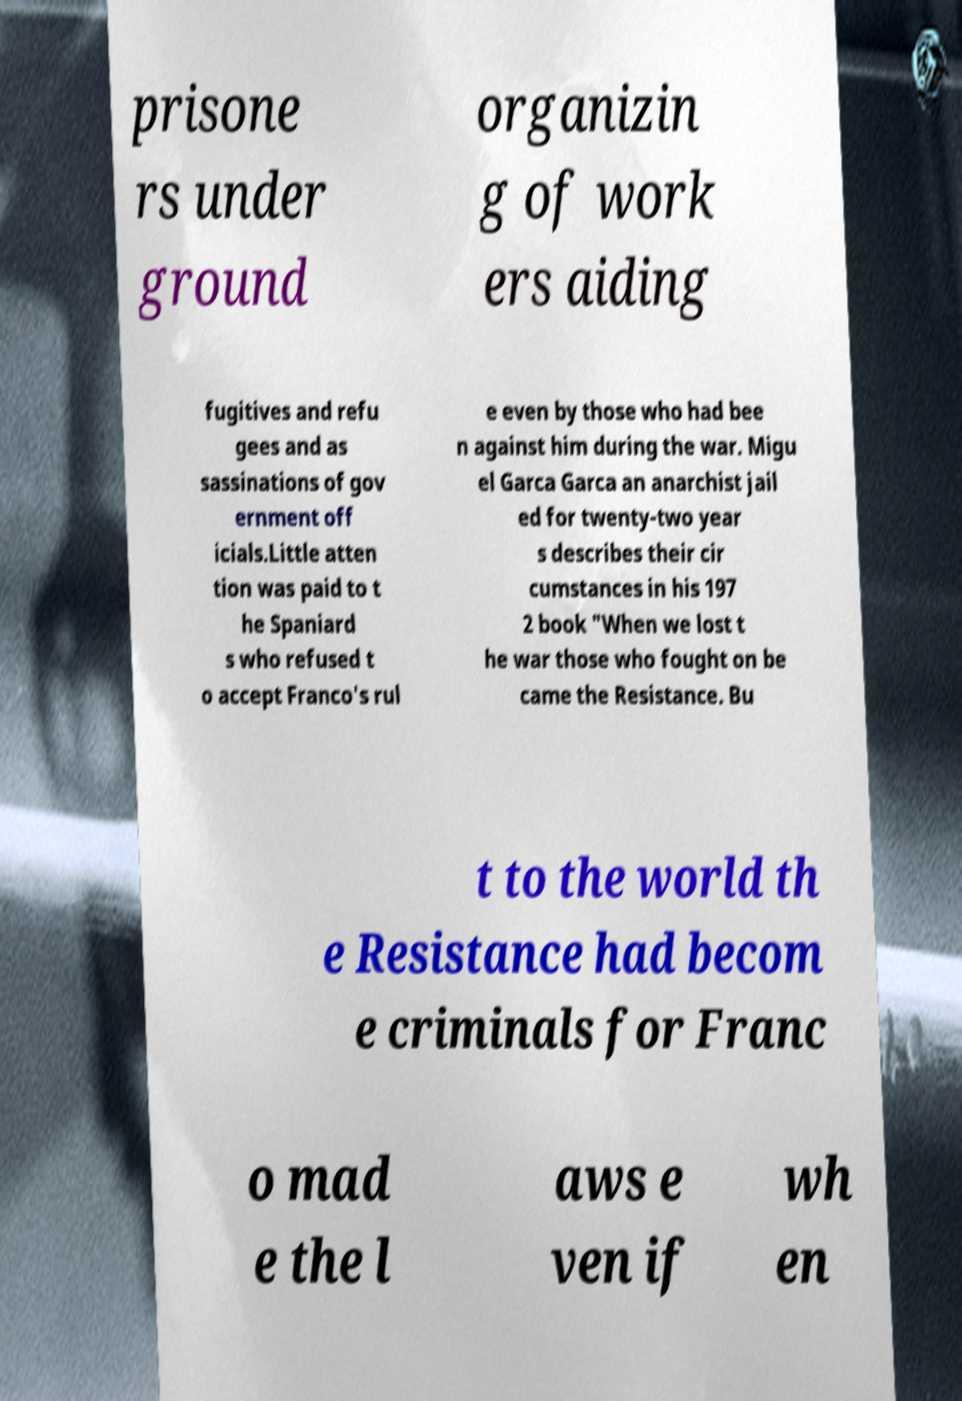Please read and relay the text visible in this image. What does it say? prisone rs under ground organizin g of work ers aiding fugitives and refu gees and as sassinations of gov ernment off icials.Little atten tion was paid to t he Spaniard s who refused t o accept Franco's rul e even by those who had bee n against him during the war. Migu el Garca Garca an anarchist jail ed for twenty-two year s describes their cir cumstances in his 197 2 book "When we lost t he war those who fought on be came the Resistance. Bu t to the world th e Resistance had becom e criminals for Franc o mad e the l aws e ven if wh en 